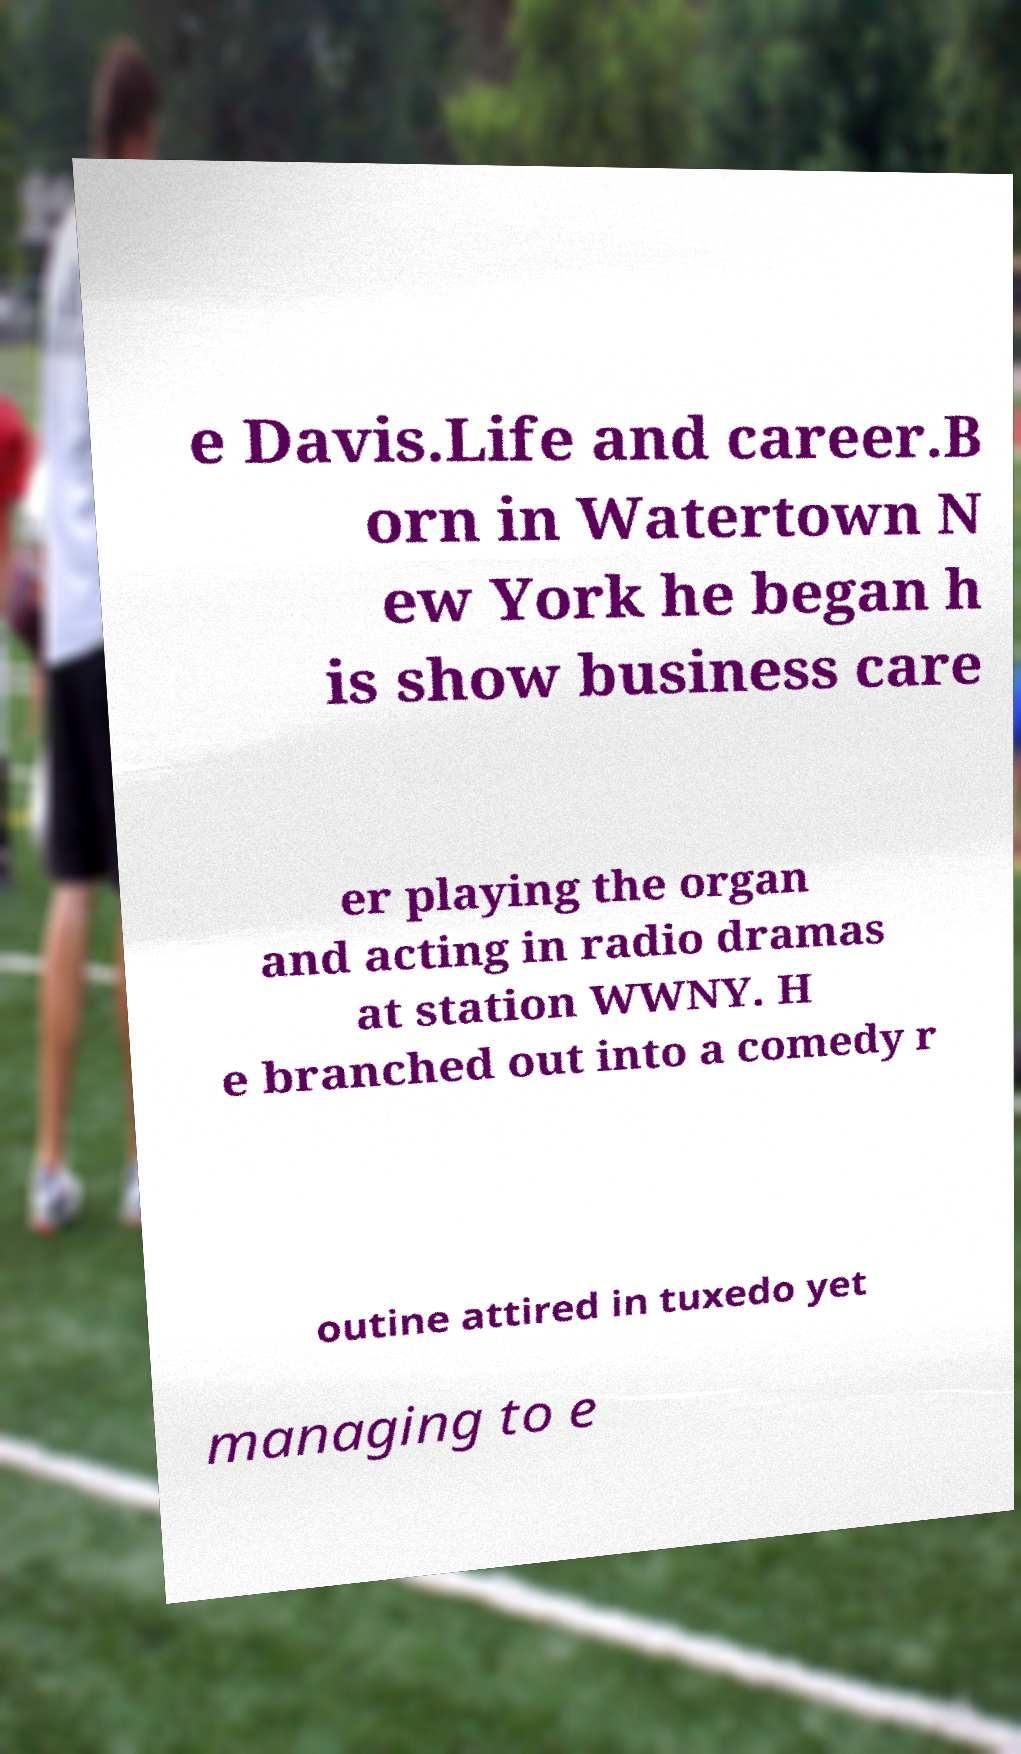Could you extract and type out the text from this image? e Davis.Life and career.B orn in Watertown N ew York he began h is show business care er playing the organ and acting in radio dramas at station WWNY. H e branched out into a comedy r outine attired in tuxedo yet managing to e 